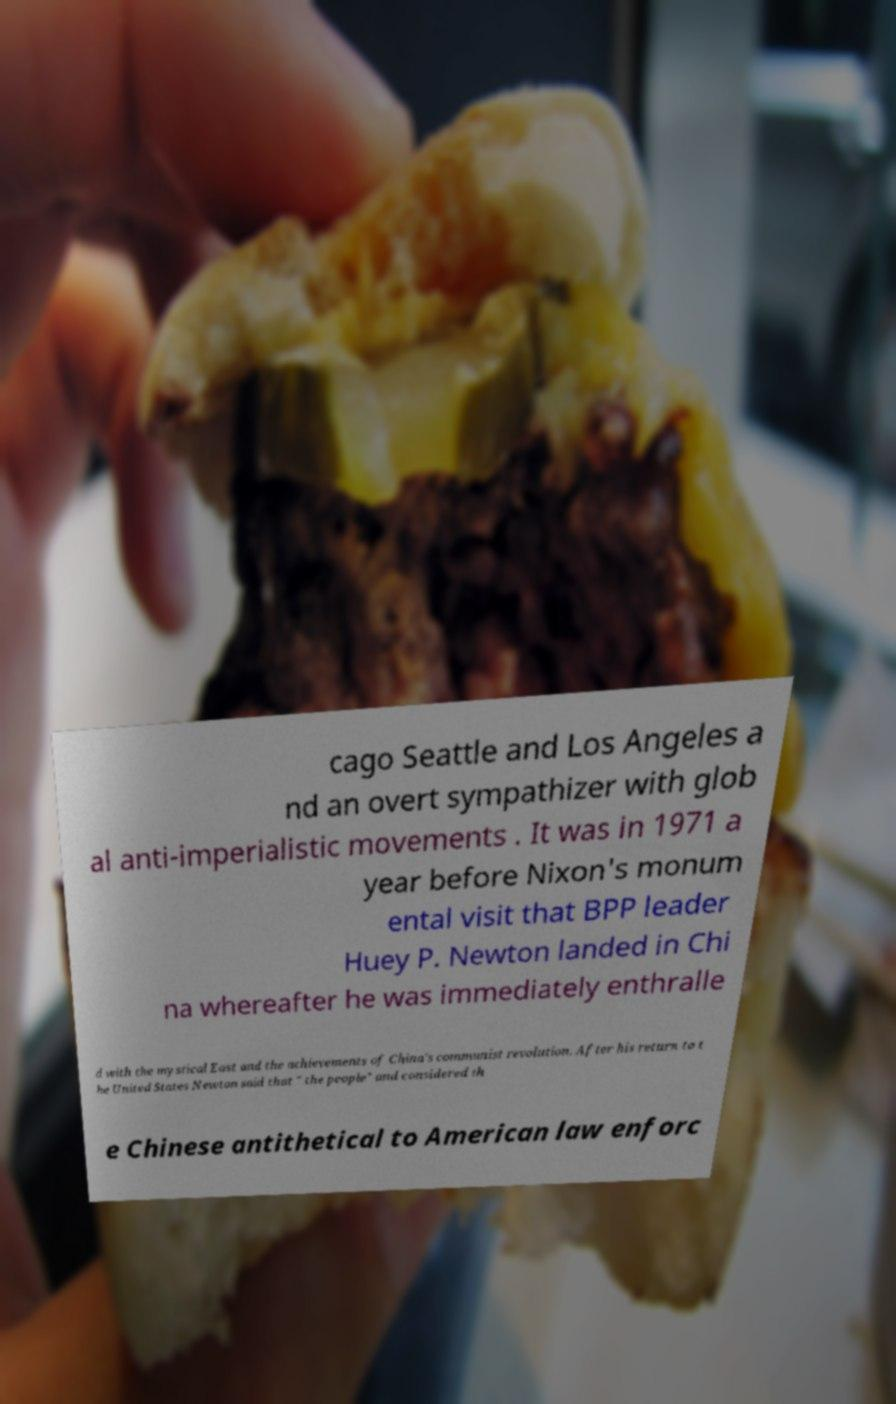Can you accurately transcribe the text from the provided image for me? cago Seattle and Los Angeles a nd an overt sympathizer with glob al anti-imperialistic movements . It was in 1971 a year before Nixon's monum ental visit that BPP leader Huey P. Newton landed in Chi na whereafter he was immediately enthralle d with the mystical East and the achievements of China's communist revolution. After his return to t he United States Newton said that " the people" and considered th e Chinese antithetical to American law enforc 